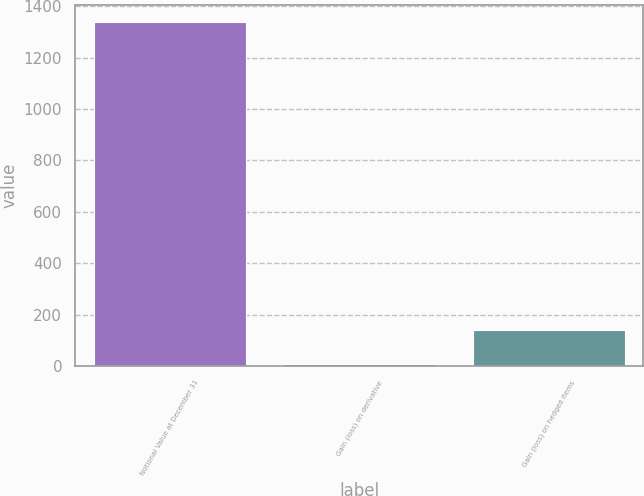<chart> <loc_0><loc_0><loc_500><loc_500><bar_chart><fcel>Notional Value at December 31<fcel>Gain (loss) on derivative<fcel>Gain (loss) on hedged items<nl><fcel>1338<fcel>6<fcel>139.2<nl></chart> 